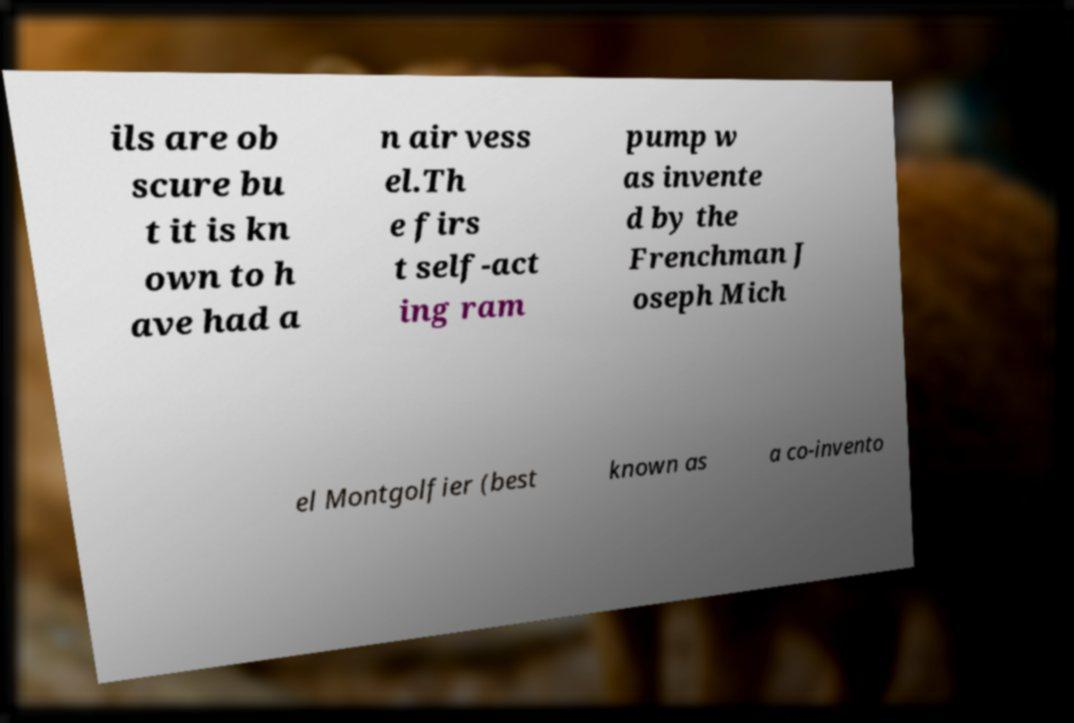Please identify and transcribe the text found in this image. ils are ob scure bu t it is kn own to h ave had a n air vess el.Th e firs t self-act ing ram pump w as invente d by the Frenchman J oseph Mich el Montgolfier (best known as a co-invento 